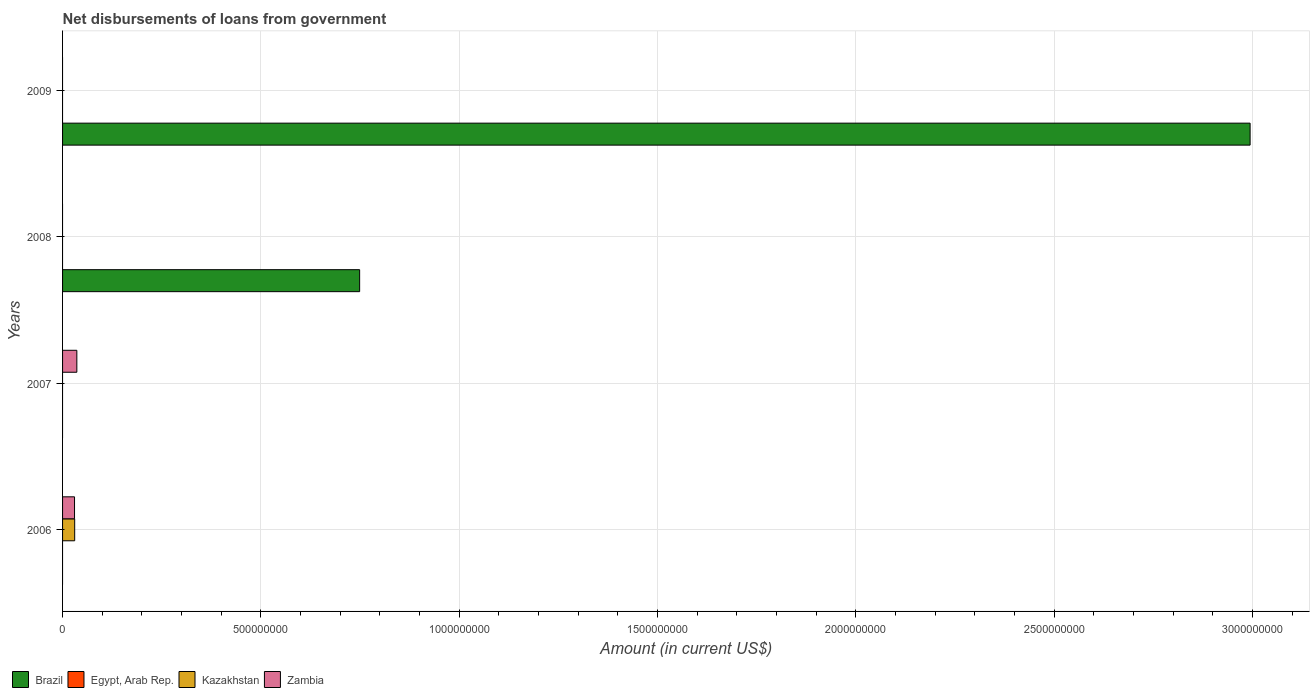Are the number of bars per tick equal to the number of legend labels?
Ensure brevity in your answer.  No. Are the number of bars on each tick of the Y-axis equal?
Keep it short and to the point. No. How many bars are there on the 1st tick from the top?
Provide a succinct answer. 1. What is the label of the 4th group of bars from the top?
Your response must be concise. 2006. In how many cases, is the number of bars for a given year not equal to the number of legend labels?
Ensure brevity in your answer.  4. Across all years, what is the maximum amount of loan disbursed from government in Zambia?
Ensure brevity in your answer.  3.60e+07. Across all years, what is the minimum amount of loan disbursed from government in Zambia?
Offer a very short reply. 0. In which year was the amount of loan disbursed from government in Zambia maximum?
Ensure brevity in your answer.  2007. What is the difference between the amount of loan disbursed from government in Brazil in 2008 and that in 2009?
Keep it short and to the point. -2.24e+09. What is the difference between the amount of loan disbursed from government in Kazakhstan in 2009 and the amount of loan disbursed from government in Brazil in 2008?
Make the answer very short. -7.49e+08. What is the average amount of loan disbursed from government in Zambia per year?
Provide a succinct answer. 1.65e+07. What is the ratio of the amount of loan disbursed from government in Brazil in 2008 to that in 2009?
Give a very brief answer. 0.25. What is the difference between the highest and the lowest amount of loan disbursed from government in Kazakhstan?
Your response must be concise. 3.06e+07. Is it the case that in every year, the sum of the amount of loan disbursed from government in Zambia and amount of loan disbursed from government in Brazil is greater than the amount of loan disbursed from government in Egypt, Arab Rep.?
Make the answer very short. Yes. Does the graph contain any zero values?
Offer a terse response. Yes. How are the legend labels stacked?
Your response must be concise. Horizontal. What is the title of the graph?
Your answer should be compact. Net disbursements of loans from government. Does "Albania" appear as one of the legend labels in the graph?
Make the answer very short. No. What is the label or title of the Y-axis?
Your answer should be compact. Years. What is the Amount (in current US$) in Egypt, Arab Rep. in 2006?
Provide a short and direct response. 0. What is the Amount (in current US$) in Kazakhstan in 2006?
Your answer should be compact. 3.06e+07. What is the Amount (in current US$) of Zambia in 2006?
Your answer should be very brief. 3.02e+07. What is the Amount (in current US$) in Egypt, Arab Rep. in 2007?
Your response must be concise. 0. What is the Amount (in current US$) in Kazakhstan in 2007?
Your answer should be compact. 0. What is the Amount (in current US$) in Zambia in 2007?
Ensure brevity in your answer.  3.60e+07. What is the Amount (in current US$) of Brazil in 2008?
Your answer should be very brief. 7.49e+08. What is the Amount (in current US$) of Egypt, Arab Rep. in 2008?
Provide a short and direct response. 0. What is the Amount (in current US$) in Kazakhstan in 2008?
Your answer should be very brief. 0. What is the Amount (in current US$) of Zambia in 2008?
Provide a short and direct response. 0. What is the Amount (in current US$) of Brazil in 2009?
Offer a very short reply. 2.99e+09. What is the Amount (in current US$) in Kazakhstan in 2009?
Offer a terse response. 0. Across all years, what is the maximum Amount (in current US$) in Brazil?
Offer a very short reply. 2.99e+09. Across all years, what is the maximum Amount (in current US$) of Kazakhstan?
Offer a very short reply. 3.06e+07. Across all years, what is the maximum Amount (in current US$) in Zambia?
Ensure brevity in your answer.  3.60e+07. Across all years, what is the minimum Amount (in current US$) in Brazil?
Keep it short and to the point. 0. Across all years, what is the minimum Amount (in current US$) of Zambia?
Offer a very short reply. 0. What is the total Amount (in current US$) in Brazil in the graph?
Make the answer very short. 3.74e+09. What is the total Amount (in current US$) in Egypt, Arab Rep. in the graph?
Provide a short and direct response. 0. What is the total Amount (in current US$) in Kazakhstan in the graph?
Offer a very short reply. 3.06e+07. What is the total Amount (in current US$) of Zambia in the graph?
Your answer should be compact. 6.62e+07. What is the difference between the Amount (in current US$) of Zambia in 2006 and that in 2007?
Offer a very short reply. -5.82e+06. What is the difference between the Amount (in current US$) of Brazil in 2008 and that in 2009?
Make the answer very short. -2.24e+09. What is the difference between the Amount (in current US$) in Kazakhstan in 2006 and the Amount (in current US$) in Zambia in 2007?
Provide a succinct answer. -5.45e+06. What is the average Amount (in current US$) of Brazil per year?
Offer a very short reply. 9.36e+08. What is the average Amount (in current US$) in Kazakhstan per year?
Your response must be concise. 7.64e+06. What is the average Amount (in current US$) in Zambia per year?
Provide a succinct answer. 1.65e+07. In the year 2006, what is the difference between the Amount (in current US$) in Kazakhstan and Amount (in current US$) in Zambia?
Your answer should be very brief. 3.71e+05. What is the ratio of the Amount (in current US$) in Zambia in 2006 to that in 2007?
Give a very brief answer. 0.84. What is the ratio of the Amount (in current US$) in Brazil in 2008 to that in 2009?
Keep it short and to the point. 0.25. What is the difference between the highest and the lowest Amount (in current US$) of Brazil?
Provide a succinct answer. 2.99e+09. What is the difference between the highest and the lowest Amount (in current US$) of Kazakhstan?
Your answer should be compact. 3.06e+07. What is the difference between the highest and the lowest Amount (in current US$) of Zambia?
Give a very brief answer. 3.60e+07. 